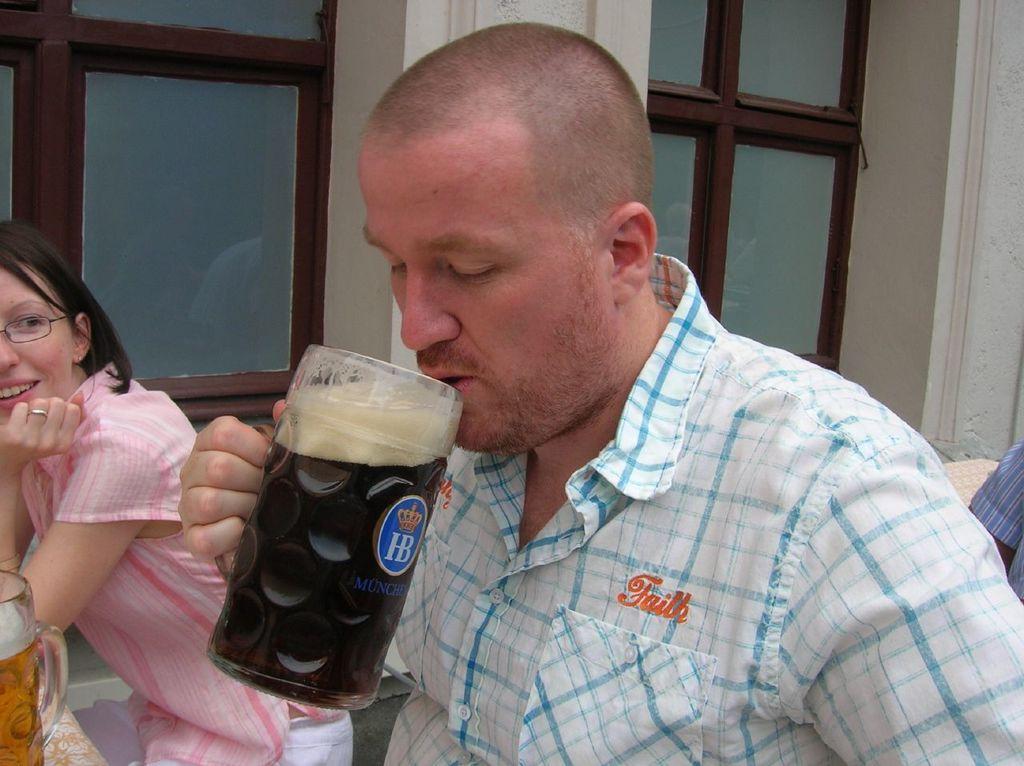Please provide a concise description of this image. In the center we can see one man he is drinking cool drink and beside him there is a lady she is smiling. 